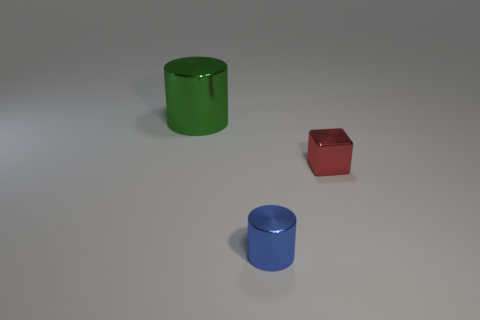Add 3 purple matte cylinders. How many objects exist? 6 Subtract all cubes. How many objects are left? 2 Subtract all tiny blue cylinders. Subtract all big blue shiny cylinders. How many objects are left? 2 Add 2 tiny metallic objects. How many tiny metallic objects are left? 4 Add 1 small metal balls. How many small metal balls exist? 1 Subtract 0 brown cubes. How many objects are left? 3 